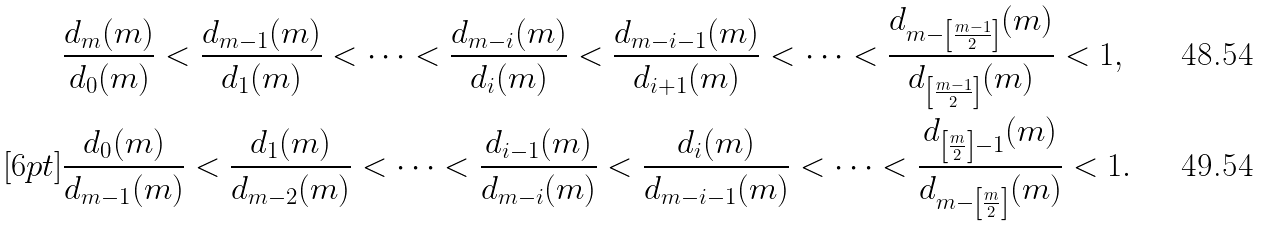<formula> <loc_0><loc_0><loc_500><loc_500>& \frac { d _ { m } ( m ) } { d _ { 0 } ( m ) } < \frac { d _ { m - 1 } ( m ) } { d _ { 1 } ( m ) } < \cdots < \frac { d _ { m - i } ( m ) } { d _ { i } ( m ) } < \frac { d _ { m - i - 1 } ( m ) } { d _ { i + 1 } ( m ) } < \cdots < \frac { d _ { m - \left [ \frac { m - 1 } { 2 } \right ] } ( m ) } { d _ { \left [ \frac { m - 1 } { 2 } \right ] } ( m ) } < 1 , \\ [ 6 p t ] & \frac { d _ { 0 } ( m ) } { d _ { m - 1 } ( m ) } < \frac { d _ { 1 } ( m ) } { d _ { m - 2 } ( m ) } < \cdots < \frac { d _ { i - 1 } ( m ) } { d _ { m - i } ( m ) } < \frac { d _ { i } ( m ) } { d _ { m - i - 1 } ( m ) } < \cdots < \frac { d _ { \left [ \frac { m } { 2 } \right ] - 1 } ( m ) } { d _ { m - \left [ \frac { m } { 2 } \right ] } ( m ) } < 1 .</formula> 